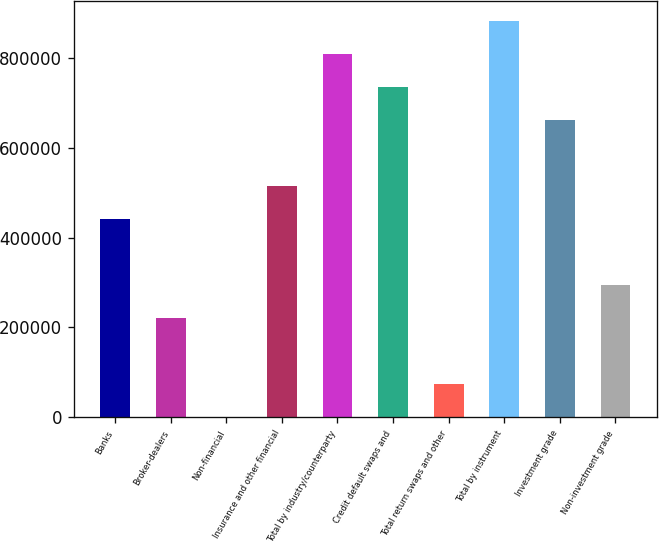Convert chart to OTSL. <chart><loc_0><loc_0><loc_500><loc_500><bar_chart><fcel>Banks<fcel>Broker-dealers<fcel>Non-financial<fcel>Insurance and other financial<fcel>Total by industry/counterparty<fcel>Credit default swaps and<fcel>Total return swaps and other<fcel>Total by instrument<fcel>Investment grade<fcel>Non-investment grade<nl><fcel>441541<fcel>221341<fcel>1140<fcel>514941<fcel>808542<fcel>735142<fcel>74540.2<fcel>881942<fcel>661742<fcel>294741<nl></chart> 